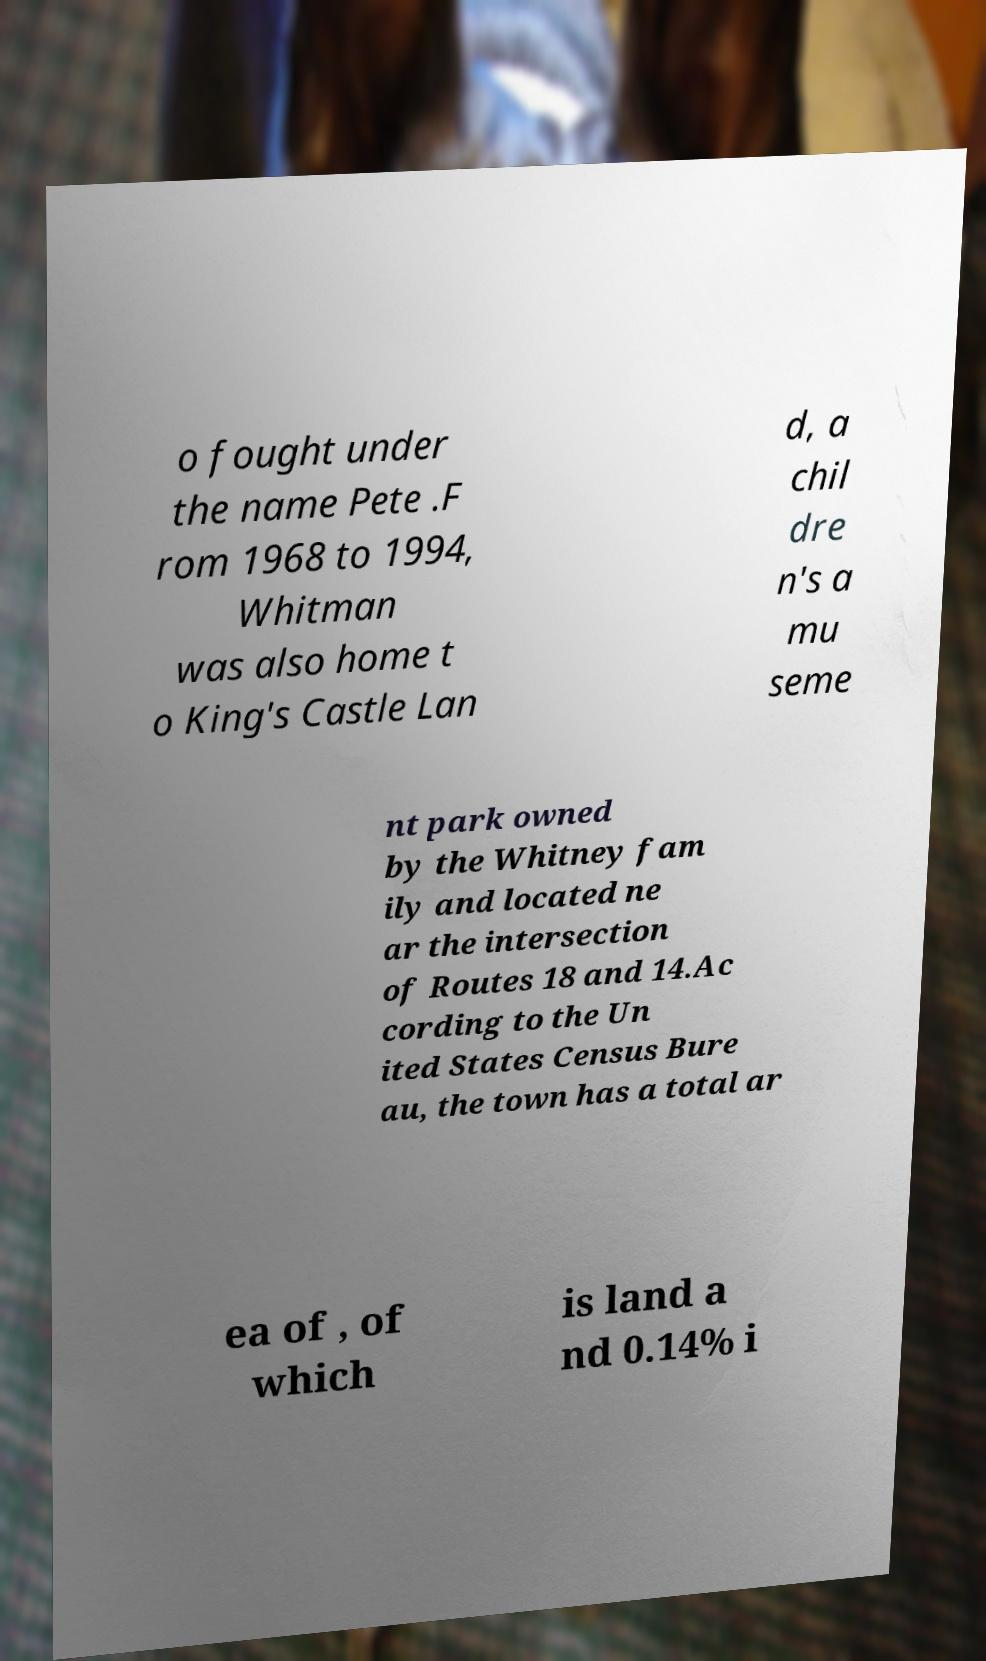What messages or text are displayed in this image? I need them in a readable, typed format. o fought under the name Pete .F rom 1968 to 1994, Whitman was also home t o King's Castle Lan d, a chil dre n's a mu seme nt park owned by the Whitney fam ily and located ne ar the intersection of Routes 18 and 14.Ac cording to the Un ited States Census Bure au, the town has a total ar ea of , of which is land a nd 0.14% i 